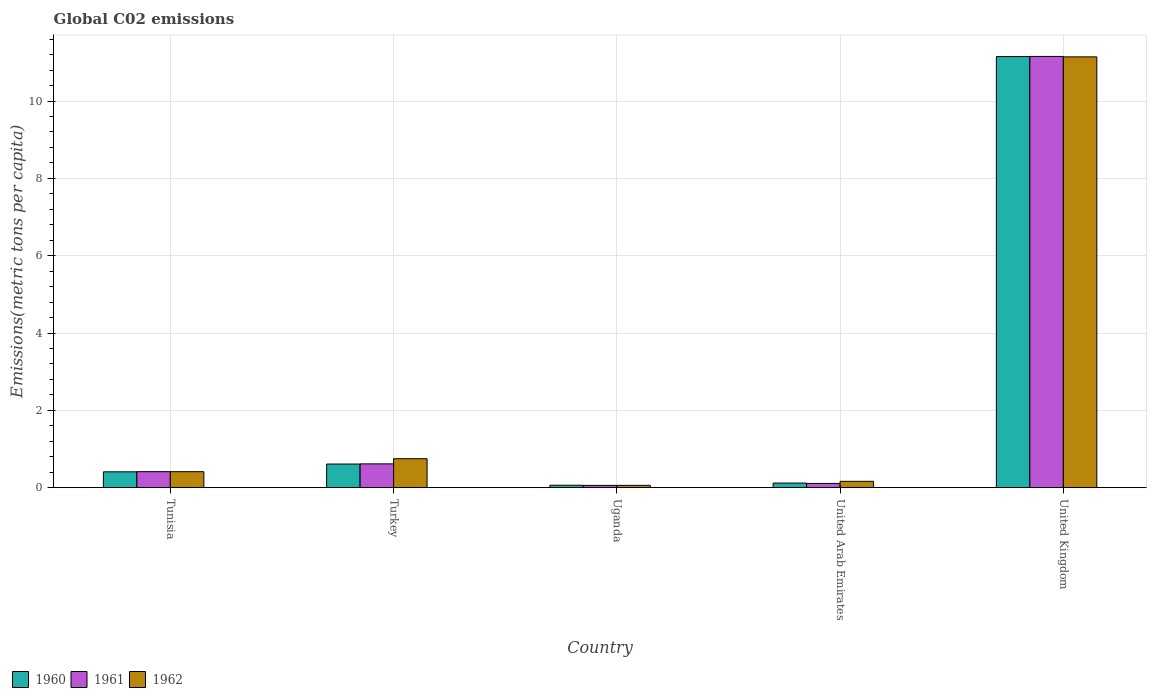Are the number of bars per tick equal to the number of legend labels?
Provide a succinct answer. Yes. Are the number of bars on each tick of the X-axis equal?
Keep it short and to the point. Yes. What is the amount of CO2 emitted in in 1960 in Uganda?
Your answer should be compact. 0.06. Across all countries, what is the maximum amount of CO2 emitted in in 1960?
Your response must be concise. 11.15. Across all countries, what is the minimum amount of CO2 emitted in in 1962?
Provide a short and direct response. 0.06. In which country was the amount of CO2 emitted in in 1960 minimum?
Your response must be concise. Uganda. What is the total amount of CO2 emitted in in 1960 in the graph?
Give a very brief answer. 12.35. What is the difference between the amount of CO2 emitted in in 1961 in Tunisia and that in United Kingdom?
Provide a succinct answer. -10.74. What is the difference between the amount of CO2 emitted in in 1961 in Turkey and the amount of CO2 emitted in in 1962 in Uganda?
Give a very brief answer. 0.56. What is the average amount of CO2 emitted in in 1962 per country?
Give a very brief answer. 2.51. What is the difference between the amount of CO2 emitted in of/in 1960 and amount of CO2 emitted in of/in 1962 in United Arab Emirates?
Provide a short and direct response. -0.04. In how many countries, is the amount of CO2 emitted in in 1961 greater than 0.4 metric tons per capita?
Your response must be concise. 3. What is the ratio of the amount of CO2 emitted in in 1960 in Uganda to that in United Arab Emirates?
Your answer should be very brief. 0.52. Is the amount of CO2 emitted in in 1962 in Tunisia less than that in Turkey?
Give a very brief answer. Yes. Is the difference between the amount of CO2 emitted in in 1960 in Tunisia and Uganda greater than the difference between the amount of CO2 emitted in in 1962 in Tunisia and Uganda?
Your response must be concise. No. What is the difference between the highest and the second highest amount of CO2 emitted in in 1961?
Your answer should be compact. -10.54. What is the difference between the highest and the lowest amount of CO2 emitted in in 1961?
Provide a succinct answer. 11.1. In how many countries, is the amount of CO2 emitted in in 1962 greater than the average amount of CO2 emitted in in 1962 taken over all countries?
Offer a terse response. 1. Is the sum of the amount of CO2 emitted in in 1962 in Tunisia and Turkey greater than the maximum amount of CO2 emitted in in 1961 across all countries?
Make the answer very short. No. What does the 1st bar from the left in United Arab Emirates represents?
Make the answer very short. 1960. Is it the case that in every country, the sum of the amount of CO2 emitted in in 1960 and amount of CO2 emitted in in 1962 is greater than the amount of CO2 emitted in in 1961?
Keep it short and to the point. Yes. How many countries are there in the graph?
Your answer should be compact. 5. What is the difference between two consecutive major ticks on the Y-axis?
Ensure brevity in your answer.  2. Does the graph contain any zero values?
Give a very brief answer. No. Does the graph contain grids?
Your response must be concise. Yes. How are the legend labels stacked?
Give a very brief answer. Horizontal. What is the title of the graph?
Offer a very short reply. Global C02 emissions. Does "2010" appear as one of the legend labels in the graph?
Make the answer very short. No. What is the label or title of the Y-axis?
Your answer should be very brief. Emissions(metric tons per capita). What is the Emissions(metric tons per capita) in 1960 in Tunisia?
Keep it short and to the point. 0.41. What is the Emissions(metric tons per capita) of 1961 in Tunisia?
Your answer should be compact. 0.41. What is the Emissions(metric tons per capita) of 1962 in Tunisia?
Ensure brevity in your answer.  0.41. What is the Emissions(metric tons per capita) in 1960 in Turkey?
Give a very brief answer. 0.61. What is the Emissions(metric tons per capita) of 1961 in Turkey?
Provide a short and direct response. 0.62. What is the Emissions(metric tons per capita) in 1962 in Turkey?
Offer a terse response. 0.75. What is the Emissions(metric tons per capita) in 1960 in Uganda?
Offer a very short reply. 0.06. What is the Emissions(metric tons per capita) of 1961 in Uganda?
Offer a very short reply. 0.06. What is the Emissions(metric tons per capita) of 1962 in Uganda?
Offer a terse response. 0.06. What is the Emissions(metric tons per capita) of 1960 in United Arab Emirates?
Keep it short and to the point. 0.12. What is the Emissions(metric tons per capita) in 1961 in United Arab Emirates?
Provide a short and direct response. 0.11. What is the Emissions(metric tons per capita) of 1962 in United Arab Emirates?
Keep it short and to the point. 0.16. What is the Emissions(metric tons per capita) in 1960 in United Kingdom?
Give a very brief answer. 11.15. What is the Emissions(metric tons per capita) of 1961 in United Kingdom?
Keep it short and to the point. 11.15. What is the Emissions(metric tons per capita) in 1962 in United Kingdom?
Make the answer very short. 11.14. Across all countries, what is the maximum Emissions(metric tons per capita) of 1960?
Provide a short and direct response. 11.15. Across all countries, what is the maximum Emissions(metric tons per capita) of 1961?
Provide a succinct answer. 11.15. Across all countries, what is the maximum Emissions(metric tons per capita) in 1962?
Your response must be concise. 11.14. Across all countries, what is the minimum Emissions(metric tons per capita) of 1960?
Keep it short and to the point. 0.06. Across all countries, what is the minimum Emissions(metric tons per capita) of 1961?
Provide a short and direct response. 0.06. Across all countries, what is the minimum Emissions(metric tons per capita) in 1962?
Ensure brevity in your answer.  0.06. What is the total Emissions(metric tons per capita) of 1960 in the graph?
Your answer should be compact. 12.35. What is the total Emissions(metric tons per capita) in 1961 in the graph?
Provide a succinct answer. 12.35. What is the total Emissions(metric tons per capita) in 1962 in the graph?
Offer a very short reply. 12.53. What is the difference between the Emissions(metric tons per capita) in 1960 in Tunisia and that in Turkey?
Make the answer very short. -0.2. What is the difference between the Emissions(metric tons per capita) in 1961 in Tunisia and that in Turkey?
Provide a succinct answer. -0.2. What is the difference between the Emissions(metric tons per capita) of 1962 in Tunisia and that in Turkey?
Keep it short and to the point. -0.34. What is the difference between the Emissions(metric tons per capita) of 1960 in Tunisia and that in Uganda?
Offer a terse response. 0.35. What is the difference between the Emissions(metric tons per capita) of 1961 in Tunisia and that in Uganda?
Keep it short and to the point. 0.36. What is the difference between the Emissions(metric tons per capita) of 1962 in Tunisia and that in Uganda?
Your response must be concise. 0.35. What is the difference between the Emissions(metric tons per capita) of 1960 in Tunisia and that in United Arab Emirates?
Your answer should be compact. 0.29. What is the difference between the Emissions(metric tons per capita) of 1961 in Tunisia and that in United Arab Emirates?
Your answer should be compact. 0.3. What is the difference between the Emissions(metric tons per capita) of 1962 in Tunisia and that in United Arab Emirates?
Give a very brief answer. 0.25. What is the difference between the Emissions(metric tons per capita) of 1960 in Tunisia and that in United Kingdom?
Offer a terse response. -10.74. What is the difference between the Emissions(metric tons per capita) of 1961 in Tunisia and that in United Kingdom?
Offer a terse response. -10.74. What is the difference between the Emissions(metric tons per capita) in 1962 in Tunisia and that in United Kingdom?
Provide a short and direct response. -10.73. What is the difference between the Emissions(metric tons per capita) in 1960 in Turkey and that in Uganda?
Keep it short and to the point. 0.55. What is the difference between the Emissions(metric tons per capita) in 1961 in Turkey and that in Uganda?
Make the answer very short. 0.56. What is the difference between the Emissions(metric tons per capita) of 1962 in Turkey and that in Uganda?
Offer a terse response. 0.69. What is the difference between the Emissions(metric tons per capita) of 1960 in Turkey and that in United Arab Emirates?
Make the answer very short. 0.49. What is the difference between the Emissions(metric tons per capita) in 1961 in Turkey and that in United Arab Emirates?
Keep it short and to the point. 0.51. What is the difference between the Emissions(metric tons per capita) of 1962 in Turkey and that in United Arab Emirates?
Make the answer very short. 0.58. What is the difference between the Emissions(metric tons per capita) of 1960 in Turkey and that in United Kingdom?
Ensure brevity in your answer.  -10.54. What is the difference between the Emissions(metric tons per capita) in 1961 in Turkey and that in United Kingdom?
Provide a short and direct response. -10.54. What is the difference between the Emissions(metric tons per capita) of 1962 in Turkey and that in United Kingdom?
Keep it short and to the point. -10.39. What is the difference between the Emissions(metric tons per capita) of 1960 in Uganda and that in United Arab Emirates?
Ensure brevity in your answer.  -0.06. What is the difference between the Emissions(metric tons per capita) in 1961 in Uganda and that in United Arab Emirates?
Give a very brief answer. -0.05. What is the difference between the Emissions(metric tons per capita) in 1962 in Uganda and that in United Arab Emirates?
Offer a terse response. -0.1. What is the difference between the Emissions(metric tons per capita) in 1960 in Uganda and that in United Kingdom?
Provide a succinct answer. -11.09. What is the difference between the Emissions(metric tons per capita) in 1961 in Uganda and that in United Kingdom?
Offer a terse response. -11.1. What is the difference between the Emissions(metric tons per capita) in 1962 in Uganda and that in United Kingdom?
Offer a very short reply. -11.08. What is the difference between the Emissions(metric tons per capita) of 1960 in United Arab Emirates and that in United Kingdom?
Provide a short and direct response. -11.03. What is the difference between the Emissions(metric tons per capita) in 1961 in United Arab Emirates and that in United Kingdom?
Provide a succinct answer. -11.05. What is the difference between the Emissions(metric tons per capita) of 1962 in United Arab Emirates and that in United Kingdom?
Offer a terse response. -10.98. What is the difference between the Emissions(metric tons per capita) of 1960 in Tunisia and the Emissions(metric tons per capita) of 1961 in Turkey?
Your answer should be very brief. -0.21. What is the difference between the Emissions(metric tons per capita) in 1960 in Tunisia and the Emissions(metric tons per capita) in 1962 in Turkey?
Keep it short and to the point. -0.34. What is the difference between the Emissions(metric tons per capita) in 1961 in Tunisia and the Emissions(metric tons per capita) in 1962 in Turkey?
Provide a short and direct response. -0.34. What is the difference between the Emissions(metric tons per capita) of 1960 in Tunisia and the Emissions(metric tons per capita) of 1961 in Uganda?
Provide a succinct answer. 0.35. What is the difference between the Emissions(metric tons per capita) in 1961 in Tunisia and the Emissions(metric tons per capita) in 1962 in Uganda?
Provide a succinct answer. 0.35. What is the difference between the Emissions(metric tons per capita) in 1960 in Tunisia and the Emissions(metric tons per capita) in 1961 in United Arab Emirates?
Offer a very short reply. 0.3. What is the difference between the Emissions(metric tons per capita) of 1960 in Tunisia and the Emissions(metric tons per capita) of 1962 in United Arab Emirates?
Provide a short and direct response. 0.25. What is the difference between the Emissions(metric tons per capita) of 1961 in Tunisia and the Emissions(metric tons per capita) of 1962 in United Arab Emirates?
Give a very brief answer. 0.25. What is the difference between the Emissions(metric tons per capita) of 1960 in Tunisia and the Emissions(metric tons per capita) of 1961 in United Kingdom?
Your answer should be very brief. -10.74. What is the difference between the Emissions(metric tons per capita) of 1960 in Tunisia and the Emissions(metric tons per capita) of 1962 in United Kingdom?
Provide a short and direct response. -10.73. What is the difference between the Emissions(metric tons per capita) in 1961 in Tunisia and the Emissions(metric tons per capita) in 1962 in United Kingdom?
Your answer should be very brief. -10.73. What is the difference between the Emissions(metric tons per capita) of 1960 in Turkey and the Emissions(metric tons per capita) of 1961 in Uganda?
Offer a very short reply. 0.55. What is the difference between the Emissions(metric tons per capita) of 1960 in Turkey and the Emissions(metric tons per capita) of 1962 in Uganda?
Offer a very short reply. 0.55. What is the difference between the Emissions(metric tons per capita) in 1961 in Turkey and the Emissions(metric tons per capita) in 1962 in Uganda?
Keep it short and to the point. 0.56. What is the difference between the Emissions(metric tons per capita) of 1960 in Turkey and the Emissions(metric tons per capita) of 1961 in United Arab Emirates?
Provide a succinct answer. 0.5. What is the difference between the Emissions(metric tons per capita) of 1960 in Turkey and the Emissions(metric tons per capita) of 1962 in United Arab Emirates?
Your response must be concise. 0.45. What is the difference between the Emissions(metric tons per capita) of 1961 in Turkey and the Emissions(metric tons per capita) of 1962 in United Arab Emirates?
Offer a very short reply. 0.45. What is the difference between the Emissions(metric tons per capita) of 1960 in Turkey and the Emissions(metric tons per capita) of 1961 in United Kingdom?
Your response must be concise. -10.54. What is the difference between the Emissions(metric tons per capita) of 1960 in Turkey and the Emissions(metric tons per capita) of 1962 in United Kingdom?
Give a very brief answer. -10.53. What is the difference between the Emissions(metric tons per capita) of 1961 in Turkey and the Emissions(metric tons per capita) of 1962 in United Kingdom?
Your answer should be compact. -10.53. What is the difference between the Emissions(metric tons per capita) in 1960 in Uganda and the Emissions(metric tons per capita) in 1961 in United Arab Emirates?
Give a very brief answer. -0.05. What is the difference between the Emissions(metric tons per capita) of 1960 in Uganda and the Emissions(metric tons per capita) of 1962 in United Arab Emirates?
Offer a terse response. -0.1. What is the difference between the Emissions(metric tons per capita) in 1961 in Uganda and the Emissions(metric tons per capita) in 1962 in United Arab Emirates?
Ensure brevity in your answer.  -0.11. What is the difference between the Emissions(metric tons per capita) of 1960 in Uganda and the Emissions(metric tons per capita) of 1961 in United Kingdom?
Provide a succinct answer. -11.09. What is the difference between the Emissions(metric tons per capita) in 1960 in Uganda and the Emissions(metric tons per capita) in 1962 in United Kingdom?
Make the answer very short. -11.08. What is the difference between the Emissions(metric tons per capita) in 1961 in Uganda and the Emissions(metric tons per capita) in 1962 in United Kingdom?
Offer a very short reply. -11.08. What is the difference between the Emissions(metric tons per capita) of 1960 in United Arab Emirates and the Emissions(metric tons per capita) of 1961 in United Kingdom?
Ensure brevity in your answer.  -11.04. What is the difference between the Emissions(metric tons per capita) of 1960 in United Arab Emirates and the Emissions(metric tons per capita) of 1962 in United Kingdom?
Provide a succinct answer. -11.02. What is the difference between the Emissions(metric tons per capita) of 1961 in United Arab Emirates and the Emissions(metric tons per capita) of 1962 in United Kingdom?
Keep it short and to the point. -11.03. What is the average Emissions(metric tons per capita) of 1960 per country?
Make the answer very short. 2.47. What is the average Emissions(metric tons per capita) of 1961 per country?
Your answer should be compact. 2.47. What is the average Emissions(metric tons per capita) in 1962 per country?
Your answer should be compact. 2.51. What is the difference between the Emissions(metric tons per capita) of 1960 and Emissions(metric tons per capita) of 1961 in Tunisia?
Offer a terse response. -0. What is the difference between the Emissions(metric tons per capita) of 1960 and Emissions(metric tons per capita) of 1962 in Tunisia?
Provide a short and direct response. -0. What is the difference between the Emissions(metric tons per capita) in 1960 and Emissions(metric tons per capita) in 1961 in Turkey?
Provide a succinct answer. -0. What is the difference between the Emissions(metric tons per capita) in 1960 and Emissions(metric tons per capita) in 1962 in Turkey?
Provide a short and direct response. -0.14. What is the difference between the Emissions(metric tons per capita) in 1961 and Emissions(metric tons per capita) in 1962 in Turkey?
Your answer should be compact. -0.13. What is the difference between the Emissions(metric tons per capita) in 1960 and Emissions(metric tons per capita) in 1961 in Uganda?
Offer a terse response. 0. What is the difference between the Emissions(metric tons per capita) in 1960 and Emissions(metric tons per capita) in 1962 in Uganda?
Make the answer very short. 0. What is the difference between the Emissions(metric tons per capita) in 1961 and Emissions(metric tons per capita) in 1962 in Uganda?
Your response must be concise. -0. What is the difference between the Emissions(metric tons per capita) in 1960 and Emissions(metric tons per capita) in 1961 in United Arab Emirates?
Make the answer very short. 0.01. What is the difference between the Emissions(metric tons per capita) in 1960 and Emissions(metric tons per capita) in 1962 in United Arab Emirates?
Give a very brief answer. -0.04. What is the difference between the Emissions(metric tons per capita) of 1961 and Emissions(metric tons per capita) of 1962 in United Arab Emirates?
Give a very brief answer. -0.05. What is the difference between the Emissions(metric tons per capita) of 1960 and Emissions(metric tons per capita) of 1961 in United Kingdom?
Give a very brief answer. -0. What is the difference between the Emissions(metric tons per capita) in 1960 and Emissions(metric tons per capita) in 1962 in United Kingdom?
Keep it short and to the point. 0.01. What is the difference between the Emissions(metric tons per capita) in 1961 and Emissions(metric tons per capita) in 1962 in United Kingdom?
Make the answer very short. 0.01. What is the ratio of the Emissions(metric tons per capita) in 1960 in Tunisia to that in Turkey?
Provide a short and direct response. 0.67. What is the ratio of the Emissions(metric tons per capita) of 1961 in Tunisia to that in Turkey?
Your answer should be compact. 0.67. What is the ratio of the Emissions(metric tons per capita) in 1962 in Tunisia to that in Turkey?
Offer a very short reply. 0.55. What is the ratio of the Emissions(metric tons per capita) of 1960 in Tunisia to that in Uganda?
Provide a succinct answer. 6.59. What is the ratio of the Emissions(metric tons per capita) of 1961 in Tunisia to that in Uganda?
Provide a succinct answer. 7.11. What is the ratio of the Emissions(metric tons per capita) in 1962 in Tunisia to that in Uganda?
Offer a very short reply. 6.97. What is the ratio of the Emissions(metric tons per capita) in 1960 in Tunisia to that in United Arab Emirates?
Your answer should be very brief. 3.44. What is the ratio of the Emissions(metric tons per capita) of 1961 in Tunisia to that in United Arab Emirates?
Keep it short and to the point. 3.79. What is the ratio of the Emissions(metric tons per capita) of 1962 in Tunisia to that in United Arab Emirates?
Ensure brevity in your answer.  2.53. What is the ratio of the Emissions(metric tons per capita) of 1960 in Tunisia to that in United Kingdom?
Ensure brevity in your answer.  0.04. What is the ratio of the Emissions(metric tons per capita) in 1961 in Tunisia to that in United Kingdom?
Your response must be concise. 0.04. What is the ratio of the Emissions(metric tons per capita) of 1962 in Tunisia to that in United Kingdom?
Your answer should be compact. 0.04. What is the ratio of the Emissions(metric tons per capita) of 1960 in Turkey to that in Uganda?
Provide a succinct answer. 9.83. What is the ratio of the Emissions(metric tons per capita) of 1961 in Turkey to that in Uganda?
Offer a terse response. 10.59. What is the ratio of the Emissions(metric tons per capita) of 1962 in Turkey to that in Uganda?
Provide a short and direct response. 12.63. What is the ratio of the Emissions(metric tons per capita) in 1960 in Turkey to that in United Arab Emirates?
Your answer should be compact. 5.14. What is the ratio of the Emissions(metric tons per capita) in 1961 in Turkey to that in United Arab Emirates?
Make the answer very short. 5.65. What is the ratio of the Emissions(metric tons per capita) of 1962 in Turkey to that in United Arab Emirates?
Offer a terse response. 4.58. What is the ratio of the Emissions(metric tons per capita) in 1960 in Turkey to that in United Kingdom?
Ensure brevity in your answer.  0.05. What is the ratio of the Emissions(metric tons per capita) in 1961 in Turkey to that in United Kingdom?
Make the answer very short. 0.06. What is the ratio of the Emissions(metric tons per capita) of 1962 in Turkey to that in United Kingdom?
Your answer should be compact. 0.07. What is the ratio of the Emissions(metric tons per capita) in 1960 in Uganda to that in United Arab Emirates?
Give a very brief answer. 0.52. What is the ratio of the Emissions(metric tons per capita) in 1961 in Uganda to that in United Arab Emirates?
Ensure brevity in your answer.  0.53. What is the ratio of the Emissions(metric tons per capita) of 1962 in Uganda to that in United Arab Emirates?
Make the answer very short. 0.36. What is the ratio of the Emissions(metric tons per capita) in 1960 in Uganda to that in United Kingdom?
Provide a succinct answer. 0.01. What is the ratio of the Emissions(metric tons per capita) in 1961 in Uganda to that in United Kingdom?
Provide a succinct answer. 0.01. What is the ratio of the Emissions(metric tons per capita) in 1962 in Uganda to that in United Kingdom?
Offer a terse response. 0.01. What is the ratio of the Emissions(metric tons per capita) in 1960 in United Arab Emirates to that in United Kingdom?
Your answer should be very brief. 0.01. What is the ratio of the Emissions(metric tons per capita) of 1961 in United Arab Emirates to that in United Kingdom?
Make the answer very short. 0.01. What is the ratio of the Emissions(metric tons per capita) in 1962 in United Arab Emirates to that in United Kingdom?
Your response must be concise. 0.01. What is the difference between the highest and the second highest Emissions(metric tons per capita) in 1960?
Your answer should be very brief. 10.54. What is the difference between the highest and the second highest Emissions(metric tons per capita) of 1961?
Make the answer very short. 10.54. What is the difference between the highest and the second highest Emissions(metric tons per capita) in 1962?
Provide a short and direct response. 10.39. What is the difference between the highest and the lowest Emissions(metric tons per capita) of 1960?
Offer a terse response. 11.09. What is the difference between the highest and the lowest Emissions(metric tons per capita) of 1961?
Offer a very short reply. 11.1. What is the difference between the highest and the lowest Emissions(metric tons per capita) of 1962?
Your answer should be very brief. 11.08. 